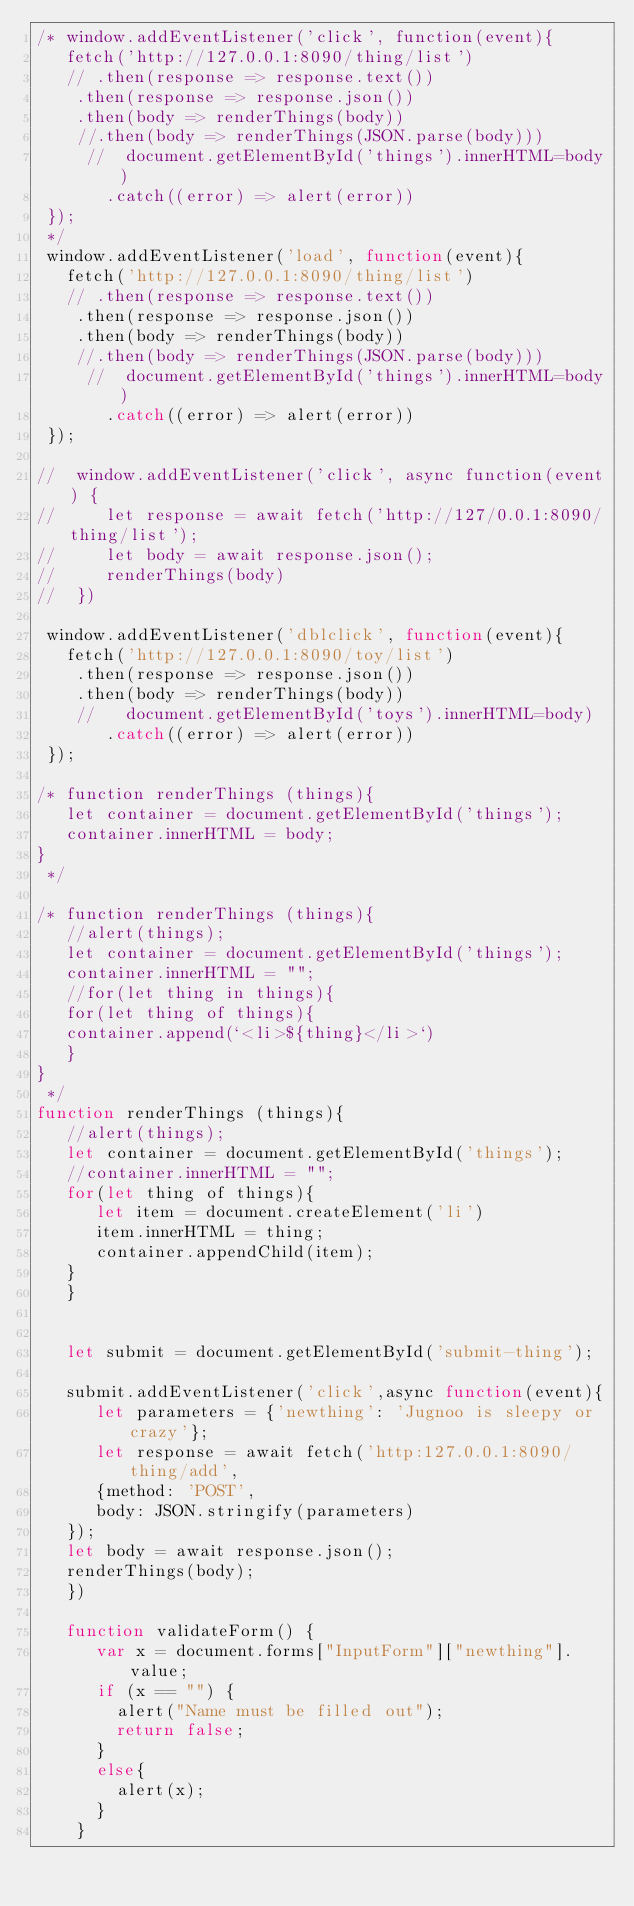<code> <loc_0><loc_0><loc_500><loc_500><_JavaScript_>/* window.addEventListener('click', function(event){
   fetch('http://127.0.0.1:8090/thing/list')
   // .then(response => response.text())
    .then(response => response.json())
    .then(body => renderThings(body))
    //.then(body => renderThings(JSON.parse(body)))
     //  document.getElementById('things').innerHTML=body)
       .catch((error) => alert(error))
 });
 */
 window.addEventListener('load', function(event){
   fetch('http://127.0.0.1:8090/thing/list')
   // .then(response => response.text())
    .then(response => response.json())
    .then(body => renderThings(body))
    //.then(body => renderThings(JSON.parse(body)))
     //  document.getElementById('things').innerHTML=body)
       .catch((error) => alert(error))
 });

//  window.addEventListener('click', async function(event) {
//     let response = await fetch('http://127/0.0.1:8090/thing/list');
//     let body = await response.json();
//     renderThings(body)
//  })

 window.addEventListener('dblclick', function(event){
   fetch('http://127.0.0.1:8090/toy/list')
    .then(response => response.json())
    .then(body => renderThings(body))
    //   document.getElementById('toys').innerHTML=body)
       .catch((error) => alert(error))
 });

/* function renderThings (things){
   let container = document.getElementById('things');
   container.innerHTML = body;
}
 */

/* function renderThings (things){
   //alert(things);
   let container = document.getElementById('things');
   container.innerHTML = "";
   //for(let thing in things){
   for(let thing of things){
   container.append(`<li>${thing}</li>`)
   }
}
 */
function renderThings (things){
   //alert(things);
   let container = document.getElementById('things');
   //container.innerHTML = "";
   for(let thing of things){
      let item = document.createElement('li')
      item.innerHTML = thing;
      container.appendChild(item);
   }
   }
 

   let submit = document.getElementById('submit-thing');

   submit.addEventListener('click',async function(event){
      let parameters = {'newthing': 'Jugnoo is sleepy or crazy'};
      let response = await fetch('http:127.0.0.1:8090/thing/add',
      {method: 'POST',
      body: JSON.stringify(parameters)
   });
   let body = await response.json();
   renderThings(body);
   })

   function validateForm() {
      var x = document.forms["InputForm"]["newthing"].value;
      if (x == "") {
        alert("Name must be filled out");
        return false;
      }
      else{
        alert(x);
      }
    } </code> 